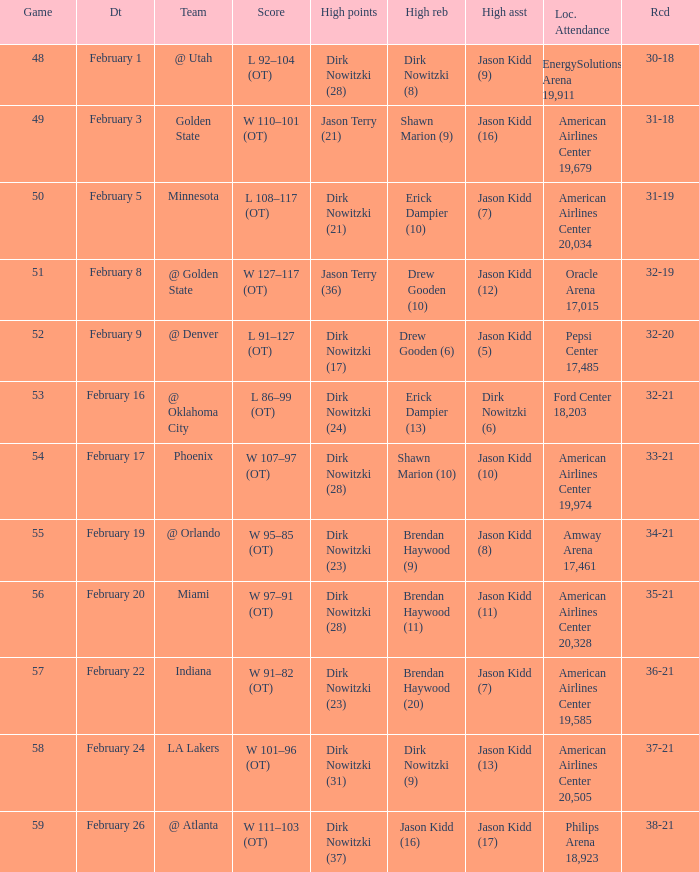When did the Mavericks have a record of 32-19? February 8. 